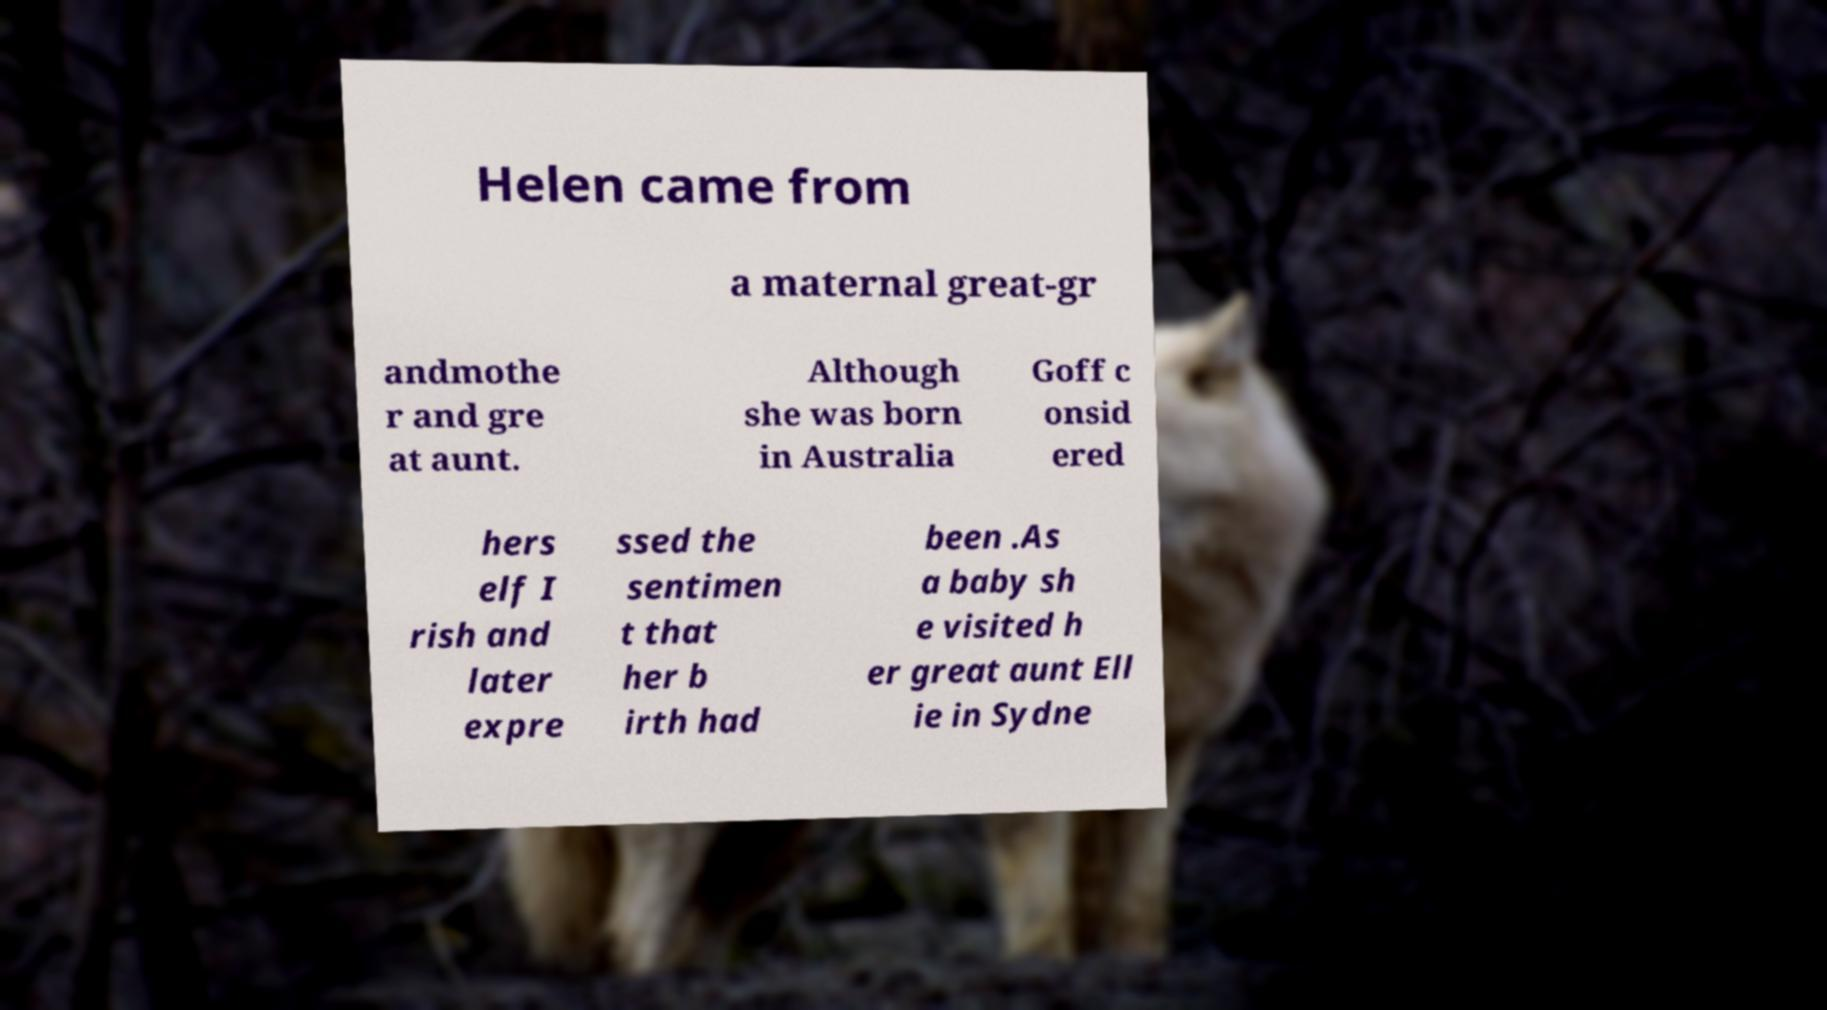I need the written content from this picture converted into text. Can you do that? Helen came from a maternal great-gr andmothe r and gre at aunt. Although she was born in Australia Goff c onsid ered hers elf I rish and later expre ssed the sentimen t that her b irth had been .As a baby sh e visited h er great aunt Ell ie in Sydne 